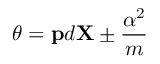<formula> <loc_0><loc_0><loc_500><loc_500>\theta = { p } d { X } \pm { \frac { \alpha ^ { 2 } } { m } }</formula> 